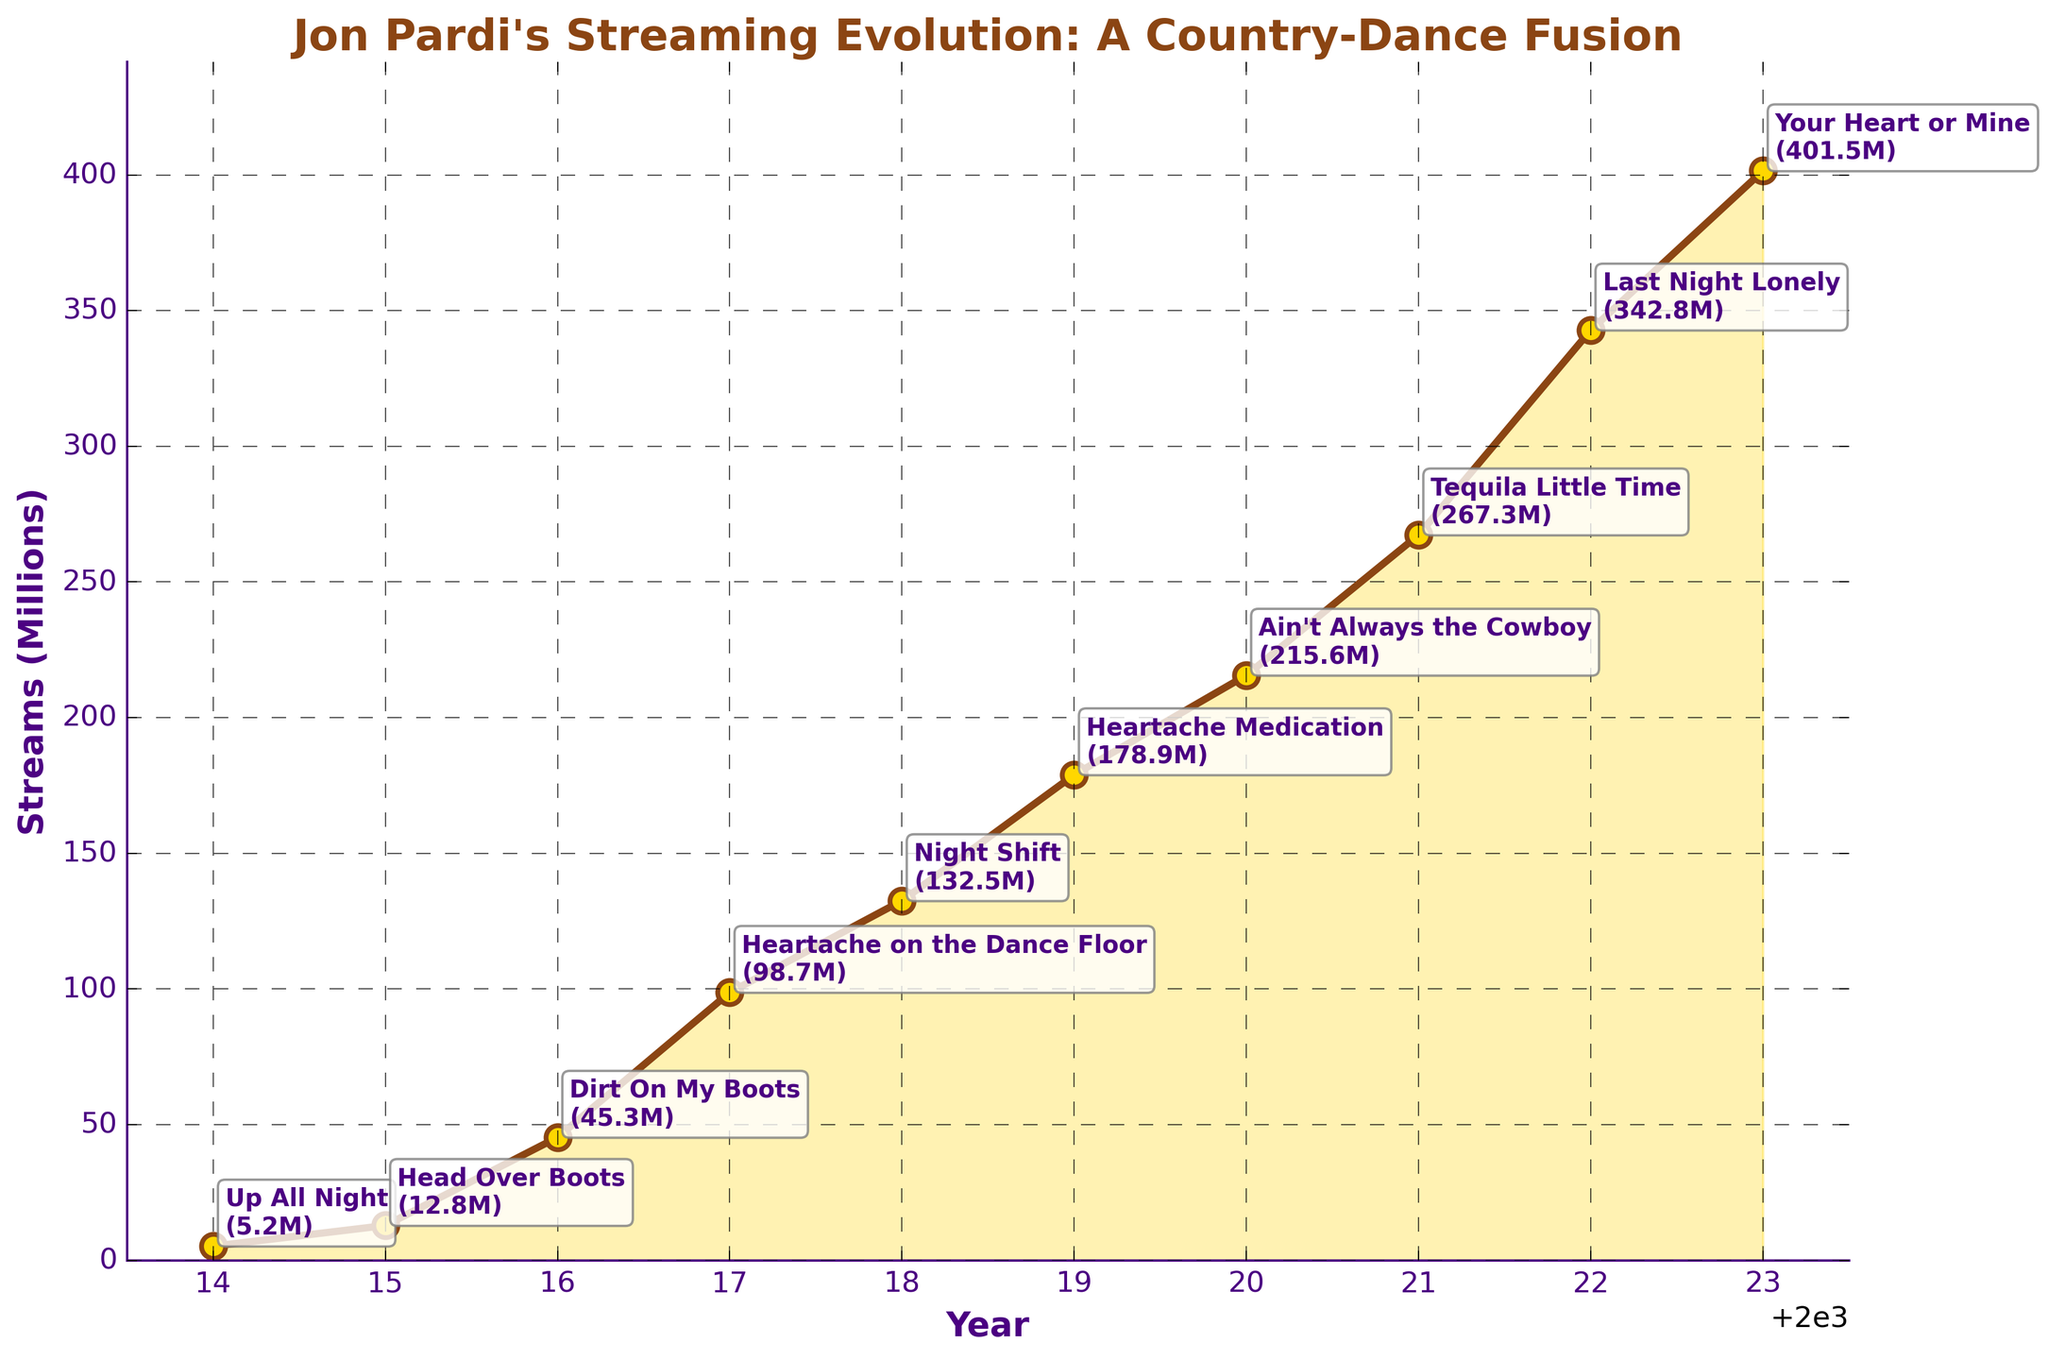What year did Jon Pardi's streaming numbers see the most significant increase? To find the year with the biggest increase in streaming numbers, look for the steepest slope between two adjacent points on the line graph. The most significant increase is between 2021 (267.3M) and 2022 (342.8M).
Answer: 2022 What is the overall trend of Jon Pardi's song popularity from 2014 to 2023? Examine if the line chart generally goes up, down, or stays level over the period. The chart shows a consistent upward trend in the streaming numbers.
Answer: Upward trend Which year had the highest stream count and what was the top song for that year? Identify the highest point on the line chart and refer to the top song annotation for that year. The highest stream count is in 2023 with "Your Heart or Mine" being the top song.
Answer: 2023, Your Heart or Mine Compare the number of streams in 2014 to 2018. How many million streams more did Jon Pardi have in 2018 compared to 2014? Subtract the streams in 2014 (5.2 million) from the streams in 2018 (132.5 million). 132.5M - 5.2M = 127.3M
Answer: 127.3M Which song had the closest streaming numbers to "Heartache Medication" and in what year? Find the year with "Heartache Medication" (2019, 178.9M) and compare it to others. "Ain't Always the Cowboy" in 2020 ranked close with 215.6M streams.
Answer: Ain't Always the Cowboy, 2020 By how many millions did the streams increase from 2016 to 2020? Subtract the streams in 2016 (45.3M) from the streams in 2020 (215.6M). 215.6M - 45.3M = 170.3M
Answer: 170.3M What visualizations highlight the overall trend of Jon Pardi’s song popularity over the years? Identify graphical elements that indicate the trend, such as the upward slope of the line, annotated points, and filled area under the curve which enhances the upward trend visualization.
Answer: Upward slope of the line, annotated points, filled area In what year did Jon Pardi cross the 100 million streams mark, and what was the top song for that year? Look at the points on the line chart to see when the streams exceed 100 million. This occurs in 2017 with "Heartache on the Dance Floor" as the top song.
Answer: 2017, Heartache on the Dance Floor How does the number of streams in 2023 compare to those in 2015 in terms of multiple times? Divide the number of streams in 2023 (401.5M) by those in 2015 (12.8M). 401.5/12.8 ≈ 31.4 times more streams in 2023.
Answer: ~31.4 times What are the years with the fewest and the most streamed songs, and what are the respective songs? Identify the lowest and highest points on the line chart. The fewest streams were in 2014 with "Up All Night" (5.2M), and the most in 2023 with "Your Heart or Mine" (401.5M).
Answer: 2014 - Up All Night, 2023 - Your Heart or Mine 